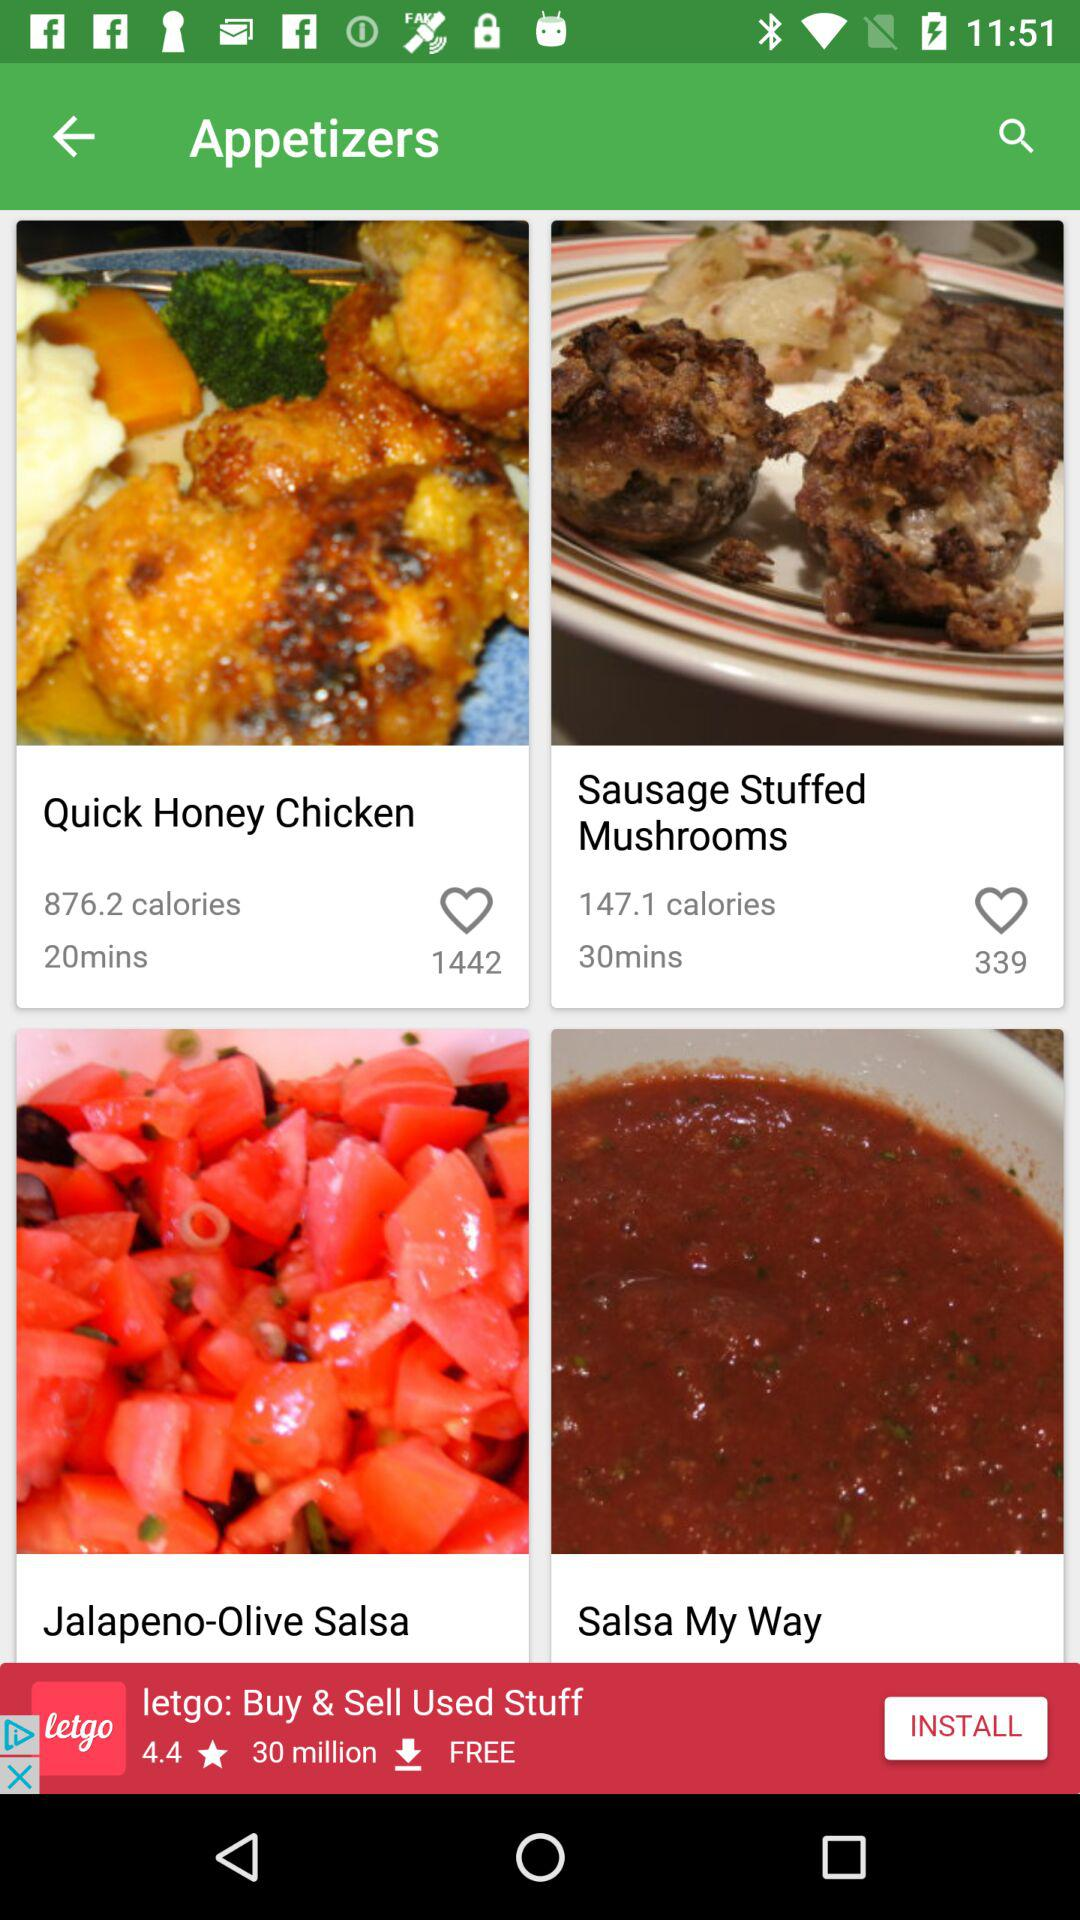How many pounds of chicken does the quick honey chicken require?
When the provided information is insufficient, respond with <no answer>. <no answer> 